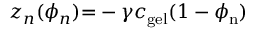<formula> <loc_0><loc_0><loc_500><loc_500>z _ { n } ( \phi _ { n } ) { = } - \gamma c _ { g e l } ( 1 - \phi _ { n } )</formula> 